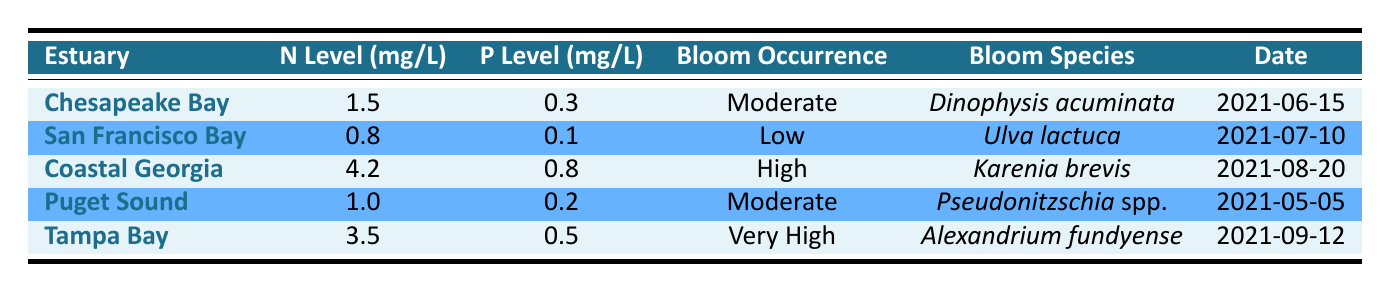What is the nitrogen level in Coastal Georgia? The table shows "NitrogenLevel_mg_L" for Coastal Georgia, which is listed as 4.2 mg/L.
Answer: 4.2 mg/L Which estuary has the highest phosphorus level? By comparing the "PhosphorusLevel_mg_L" for all estuaries, Coastal Georgia has the highest level at 0.8 mg/L.
Answer: Coastal Georgia Is the algal bloom occurrence in San Francisco Bay low? The table explicitly states that the "AlgalBloomOccurrence" for San Francisco Bay is "Low."
Answer: Yes What is the date of the algal bloom occurrence recorded in Tampa Bay? The table lists the "Date" for Tampa Bay's bloom occurrence as 2021-09-12.
Answer: 2021-09-12 What is the average nitrogen level across all the estuaries listed? To find the average nitrogen level, sum the nitrogen levels: 1.5 + 0.8 + 4.2 + 1.0 + 3.5 = 11.0. Dividing by the number of estuaries (5) gives an average of 11.0 / 5 = 2.2 mg/L.
Answer: 2.2 mg/L How many estuaries have a moderate or higher algal bloom occurrence? By examining the "AlgalBloomOccurrence" column, Chesapeake Bay and Puget Sound are moderate, Coastal Georgia is high, and Tampa Bay is very high, totaling 4 estuaries.
Answer: 4 estuaries Is there an algal bloom species listed for the Puget Sound? The table confirms that the bloom species for Puget Sound is recorded as "Pseudonitzschia spp."
Answer: Yes What is the difference in nitrogen levels between Coastal Georgia and San Francisco Bay? The nitrogen level for Coastal Georgia is 4.2 mg/L, and for San Francisco Bay, it is 0.8 mg/L. The difference is 4.2 - 0.8 = 3.4 mg/L.
Answer: 3.4 mg/L Which bloom species is associated with the highest algal bloom occurrence? The table indicates that "Karenia brevis" is the bloom species linked to the highest occurrence, which is classified as "High" in Coastal Georgia.
Answer: Karenia brevis How many of the algal bloom occurrences are categorized as 'Very High'? The table indicates that only one estuary, Tampa Bay, is categorized as having a 'Very High' algal bloom occurrence.
Answer: 1 